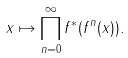Convert formula to latex. <formula><loc_0><loc_0><loc_500><loc_500>x \mapsto \prod _ { n = 0 } ^ { \infty } f ^ { * } ( f ^ { n } ( x ) ) .</formula> 